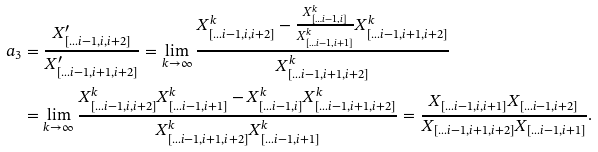Convert formula to latex. <formula><loc_0><loc_0><loc_500><loc_500>a _ { 3 } & = \frac { X ^ { \prime } _ { [ \dots i - 1 , i , i + 2 ] } } { X ^ { \prime } _ { [ \dots i - 1 , i + 1 , i + 2 ] } } = \lim _ { k \to \infty } \frac { X ^ { k } _ { [ \dots i - 1 , i , i + 2 ] } - \frac { X ^ { k } _ { [ \dots i - 1 , i ] } } { X ^ { k } _ { [ \dots i - 1 , i + 1 ] } } X ^ { k } _ { [ \dots i - 1 , i + 1 , i + 2 ] } } { X ^ { k } _ { [ \dots i - 1 , i + 1 , i + 2 ] } } \\ & = \lim _ { k \to \infty } \frac { X ^ { k } _ { [ \dots i - 1 , i , i + 2 ] } X ^ { k } _ { [ \dots i - 1 , i + 1 ] } - { X ^ { k } _ { [ \dots i - 1 , i ] } } X ^ { k } _ { [ \dots i - 1 , i + 1 , i + 2 ] } } { X ^ { k } _ { [ \dots i - 1 , i + 1 , i + 2 ] } X ^ { k } _ { [ \dots i - 1 , i + 1 ] } } = \frac { X _ { [ \dots i - 1 , i , i + 1 ] } X _ { [ \dots i - 1 , i + 2 ] } } { X _ { [ \dots i - 1 , i + 1 , i + 2 ] } X _ { [ \dots i - 1 , i + 1 ] } } .</formula> 